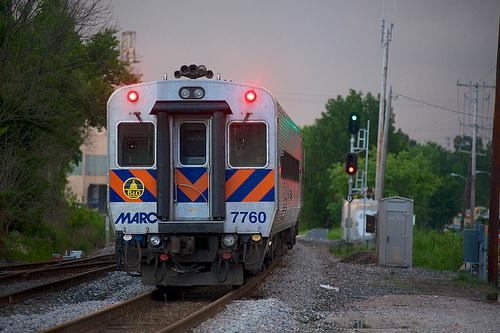What is unique about the train's appearance? The train is white with blue and orange stripes and the number 7760 on the back. Describe one element related to nature that is visible in this image. There is a green tree on the side of the train tracks. Please describe two elements found in the background of this image. Tall electrical pole with powerlines and green dense trees are in the background. What is the train doing in this image? The train is stopped on the tracks. List two objects present that contain red color. The red traffic light and the red lights on the back of the train are red objects. Mention one small object unrelated to the train that appears in the photo. A small grey shack appears in the image. Identify the color of the lights on the stoplight. The stoplight has red and green lights. What words can be found on the back of the train? "7760" and "MARC" can be seen on the back of the train. What is the condition of the train tracks? The train tracks are brown, rusted and have gravel between them. Provide a brief description of the ground around the tracks. The ground around the tracks is rough, rocky and has some piles of gravel. Does the train look like it's moving very fast? This misleading instruction suggests that the train is moving fast when the existing caption says "the train is stopped." Find a stoplight that is both green and yellow. This misleading instruction suggests to look for a stoplight that is both green and yellow, but the actual stoplights in the image are green or red, as mentioned in the captions "green and red stoplights" and "the light is red." Can you find a large lake in the photo? This misleading instruction asks about the presence of a large lake, but there is no mention of a lake in the existing captions. Instead, there's a mention of "a small puddle of water." Can you see the pink stripes on the train? This instruction is misleading because it suggests that there are pink stripes on the train when the actual stripes are blue and orange as mentioned in the captions "blue and orange stripes" and "orange and blue stripes on back." Are there any purple flowers near the railroad? This misleading instruction asks about the presence of purple flowers near the railroad when there is no mention of any flowers in the existing captions. Does the sky look bright and sunny? This misleading instruction asks if the sky is bright and sunny, but the image has captions saying "the sky is clear" and "the sky is dim." Do the train tracks appear to be shiny and new? This misleading instruction suggests the train tracks are shiny and new, but the existing captions say "the tracks are rusted" and "brown train tracks." Is there a blue door on the small grey shack? This misleading instruction asks if there's a blue door on the small grey shack. However, the actual caption mentions "the door is white." Look for a tree with red leaves. This instruction is misleading because it suggests to look for a tree with red leaves, but the existing captions mention "green dense trees" and "the tree is green." Is the light on the train green instead of red? This instruction is misleading because it suggests that the light on the train is green when it's actually red, as seen in the captions "the lights are red" and "a red traffic light." 